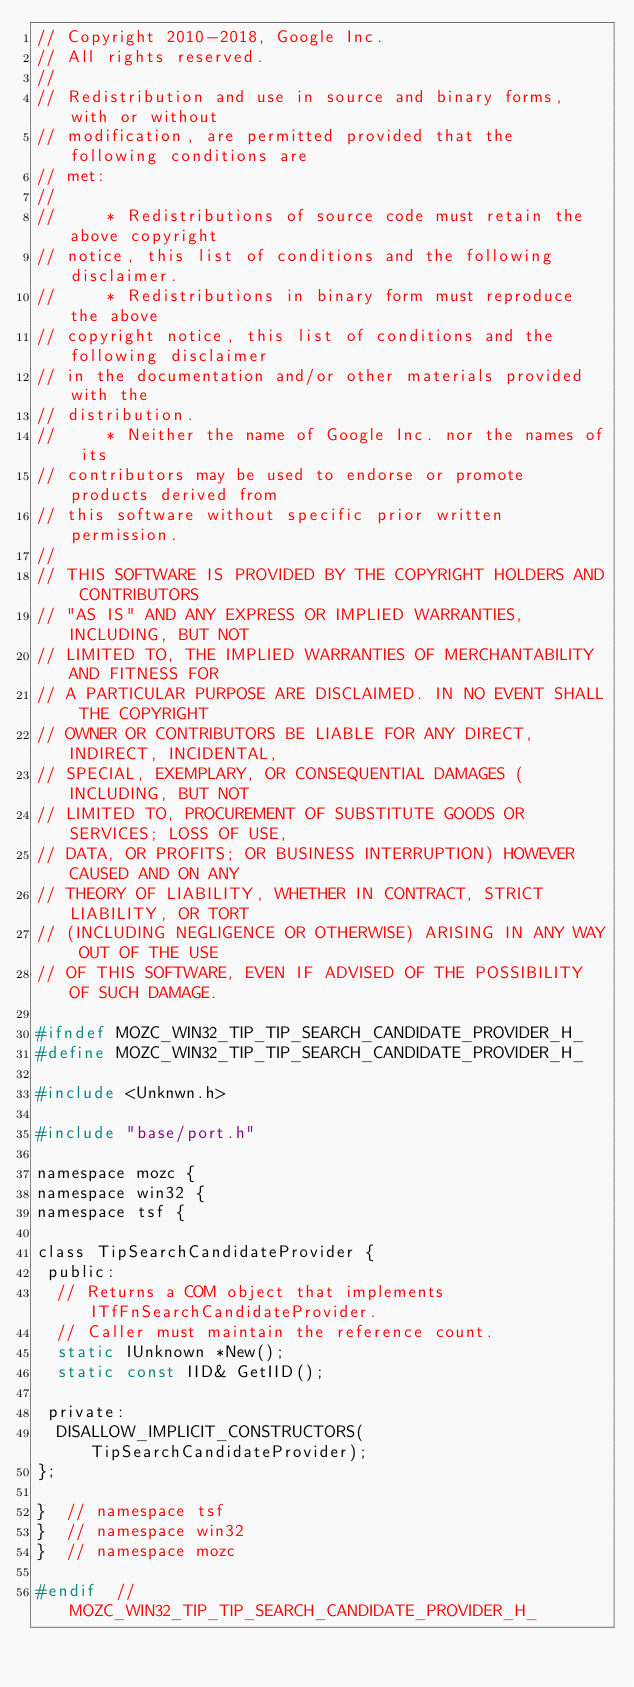Convert code to text. <code><loc_0><loc_0><loc_500><loc_500><_C_>// Copyright 2010-2018, Google Inc.
// All rights reserved.
//
// Redistribution and use in source and binary forms, with or without
// modification, are permitted provided that the following conditions are
// met:
//
//     * Redistributions of source code must retain the above copyright
// notice, this list of conditions and the following disclaimer.
//     * Redistributions in binary form must reproduce the above
// copyright notice, this list of conditions and the following disclaimer
// in the documentation and/or other materials provided with the
// distribution.
//     * Neither the name of Google Inc. nor the names of its
// contributors may be used to endorse or promote products derived from
// this software without specific prior written permission.
//
// THIS SOFTWARE IS PROVIDED BY THE COPYRIGHT HOLDERS AND CONTRIBUTORS
// "AS IS" AND ANY EXPRESS OR IMPLIED WARRANTIES, INCLUDING, BUT NOT
// LIMITED TO, THE IMPLIED WARRANTIES OF MERCHANTABILITY AND FITNESS FOR
// A PARTICULAR PURPOSE ARE DISCLAIMED. IN NO EVENT SHALL THE COPYRIGHT
// OWNER OR CONTRIBUTORS BE LIABLE FOR ANY DIRECT, INDIRECT, INCIDENTAL,
// SPECIAL, EXEMPLARY, OR CONSEQUENTIAL DAMAGES (INCLUDING, BUT NOT
// LIMITED TO, PROCUREMENT OF SUBSTITUTE GOODS OR SERVICES; LOSS OF USE,
// DATA, OR PROFITS; OR BUSINESS INTERRUPTION) HOWEVER CAUSED AND ON ANY
// THEORY OF LIABILITY, WHETHER IN CONTRACT, STRICT LIABILITY, OR TORT
// (INCLUDING NEGLIGENCE OR OTHERWISE) ARISING IN ANY WAY OUT OF THE USE
// OF THIS SOFTWARE, EVEN IF ADVISED OF THE POSSIBILITY OF SUCH DAMAGE.

#ifndef MOZC_WIN32_TIP_TIP_SEARCH_CANDIDATE_PROVIDER_H_
#define MOZC_WIN32_TIP_TIP_SEARCH_CANDIDATE_PROVIDER_H_

#include <Unknwn.h>

#include "base/port.h"

namespace mozc {
namespace win32 {
namespace tsf {

class TipSearchCandidateProvider {
 public:
  // Returns a COM object that implements ITfFnSearchCandidateProvider.
  // Caller must maintain the reference count.
  static IUnknown *New();
  static const IID& GetIID();

 private:
  DISALLOW_IMPLICIT_CONSTRUCTORS(TipSearchCandidateProvider);
};

}  // namespace tsf
}  // namespace win32
}  // namespace mozc

#endif  // MOZC_WIN32_TIP_TIP_SEARCH_CANDIDATE_PROVIDER_H_
</code> 